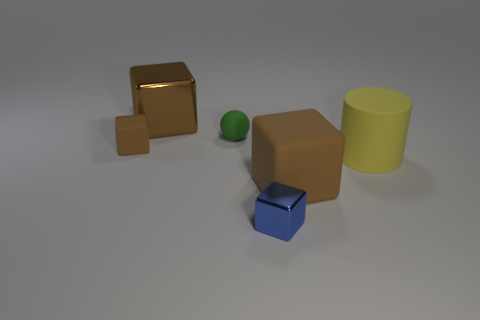What number of blue things are big cylinders or tiny things?
Offer a terse response. 1. There is a brown rubber block behind the brown matte block that is to the right of the tiny rubber cube; what size is it?
Ensure brevity in your answer.  Small. Does the sphere have the same color as the block behind the tiny green rubber thing?
Keep it short and to the point. No. How many other things are there of the same material as the blue thing?
Offer a very short reply. 1. The green object that is the same material as the large yellow thing is what shape?
Give a very brief answer. Sphere. Is there any other thing that is the same color as the matte ball?
Offer a terse response. No. What size is the other matte block that is the same color as the big rubber block?
Provide a short and direct response. Small. Are there more green matte balls that are left of the large rubber block than red shiny spheres?
Offer a terse response. Yes. There is a blue thing; is it the same shape as the big brown thing right of the blue cube?
Your answer should be very brief. Yes. How many metallic cubes have the same size as the green matte object?
Offer a very short reply. 1. 